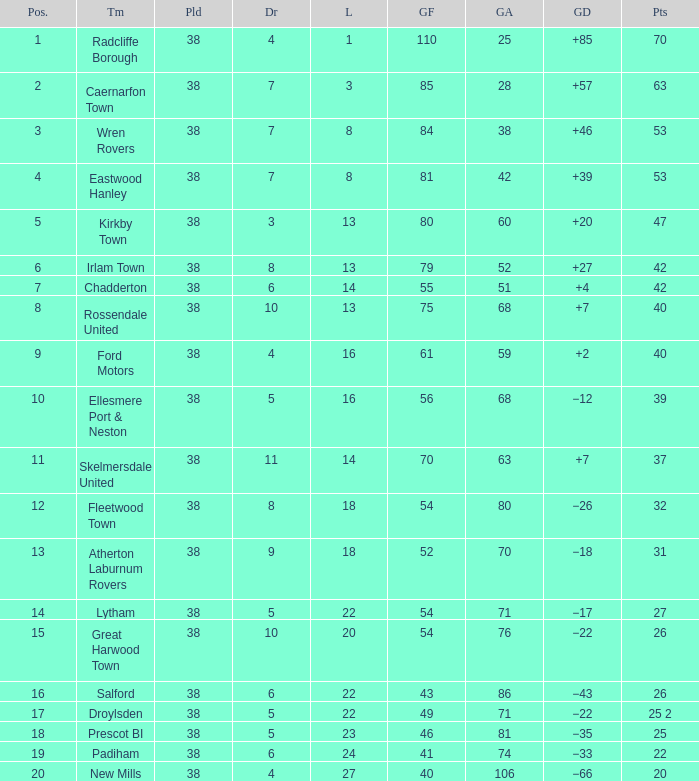Which Played has a Drawn of 4, and a Position of 9, and Goals Against larger than 59? None. 